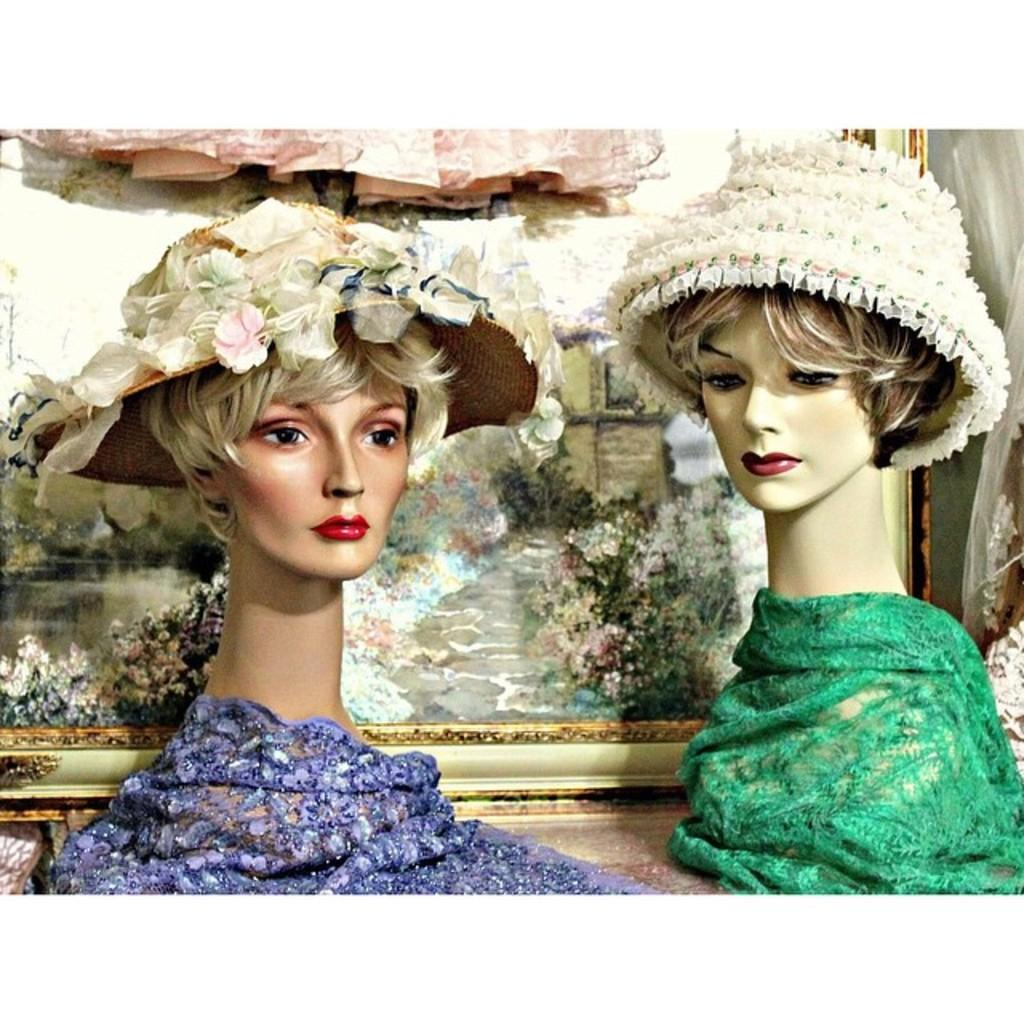What can be seen in the foreground of the image? There are two toys in the foreground of the image. What are the toys wearing? The toys are wearing hats. What is visible in the background of the image? There is a photo frame in the background of the image, along with other objects. What type of health news is being discussed by the toys in the image? There is no indication in the image that the toys are discussing any news, health-related or otherwise. 